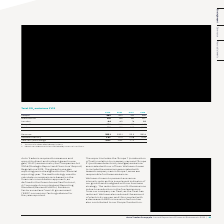According to Auto Trader's financial document, What are the units used when representing the Total CO2 emissions? Tonnes of carbon dioxide equivalent.. The document states: "1 Tonnes of carbon dioxide equivalent. 2 Absolute carbon emissions divided by revenue in millions...." Also, How is carbon intensity calculated? Absolute carbon emissions divided by revenue in millions.. The document states: "1 Tonnes of carbon dioxide equivalent. 2 Absolute carbon emissions divided by revenue in millions...." Also, Which items in the table are used to calculate the carbon intensity? The document shows two values: Total and Revenue. From the document: "Total 521 731 928 1,010 Revenue 355.1 330.1 311.5 281.6..." Additionally, In which year was the CO2 emissions amount in London largest? According to the financial document, FY16. The relevant text states: "FY19 FY18 FY17 FY16..." Also, can you calculate: What was the change in the CO2 emissions amount in London in 2019 from 2018? Based on the calculation: 44-60, the result is -16. This is based on the information: "London 44 60 76 88 London 44 60 76 88..." The key data points involved are: 44, 60. Also, can you calculate: What was the percentage change in the CO2 emissions amount in London in 2019 from 2018? To answer this question, I need to perform calculations using the financial data. The calculation is: (44-60)/60, which equals -26.67 (percentage). This is based on the information: "London 44 60 76 88 London 44 60 76 88..." The key data points involved are: 44, 60. 